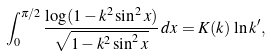Convert formula to latex. <formula><loc_0><loc_0><loc_500><loc_500>\int _ { 0 } ^ { \pi / 2 } \frac { \log ( 1 - k ^ { 2 } \sin ^ { 2 } x ) } { \sqrt { 1 - k ^ { 2 } \sin ^ { 2 } x } } \, d x = K ( k ) \, \ln k ^ { \prime } ,</formula> 